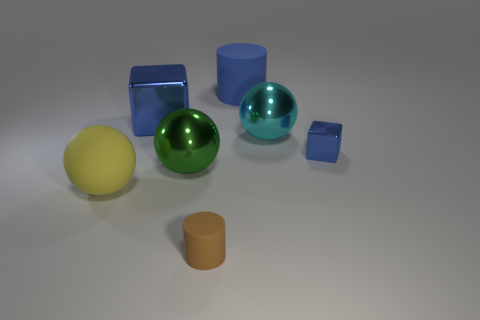What shape is the metal object that is the same size as the brown matte thing?
Your answer should be very brief. Cube. What number of other objects are the same color as the big metal block?
Keep it short and to the point. 2. How many blue metallic objects are there?
Keep it short and to the point. 2. How many tiny things are to the left of the big rubber cylinder and to the right of the blue matte object?
Provide a short and direct response. 0. What is the material of the big blue cube?
Provide a short and direct response. Metal. Are any small brown things visible?
Give a very brief answer. Yes. The matte cylinder in front of the yellow thing is what color?
Your response must be concise. Brown. How many large yellow matte objects are behind the big object behind the big blue object that is in front of the big blue cylinder?
Ensure brevity in your answer.  0. There is a big ball that is to the left of the blue cylinder and to the right of the rubber sphere; what material is it?
Your answer should be compact. Metal. Do the big blue cylinder and the green sphere in front of the tiny blue shiny cube have the same material?
Give a very brief answer. No. 